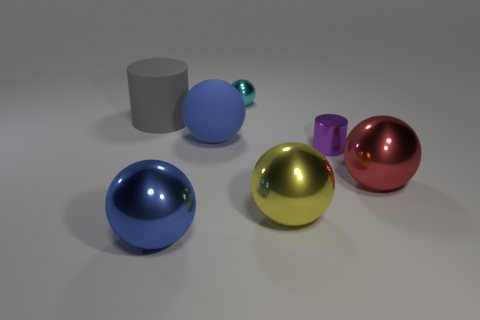There is a cylinder in front of the blue rubber sphere; is its size the same as the metal ball that is in front of the big yellow metal thing?
Your answer should be very brief. No. There is a metallic thing that is the same color as the matte sphere; what size is it?
Keep it short and to the point. Large. There is a object that is the same color as the large rubber sphere; what material is it?
Ensure brevity in your answer.  Metal. There is another blue object that is the same shape as the big blue metallic object; what is it made of?
Offer a very short reply. Rubber. Are there any big balls on the left side of the big red sphere?
Offer a terse response. Yes. Does the big red ball right of the tiny purple cylinder have the same material as the yellow sphere?
Offer a very short reply. Yes. Is there a metallic thing that has the same color as the big rubber sphere?
Your response must be concise. Yes. There is a purple shiny thing; what shape is it?
Your answer should be compact. Cylinder. What color is the shiny sphere behind the large metallic object behind the big yellow shiny ball?
Ensure brevity in your answer.  Cyan. What size is the metallic sphere behind the red shiny sphere?
Provide a succinct answer. Small. 